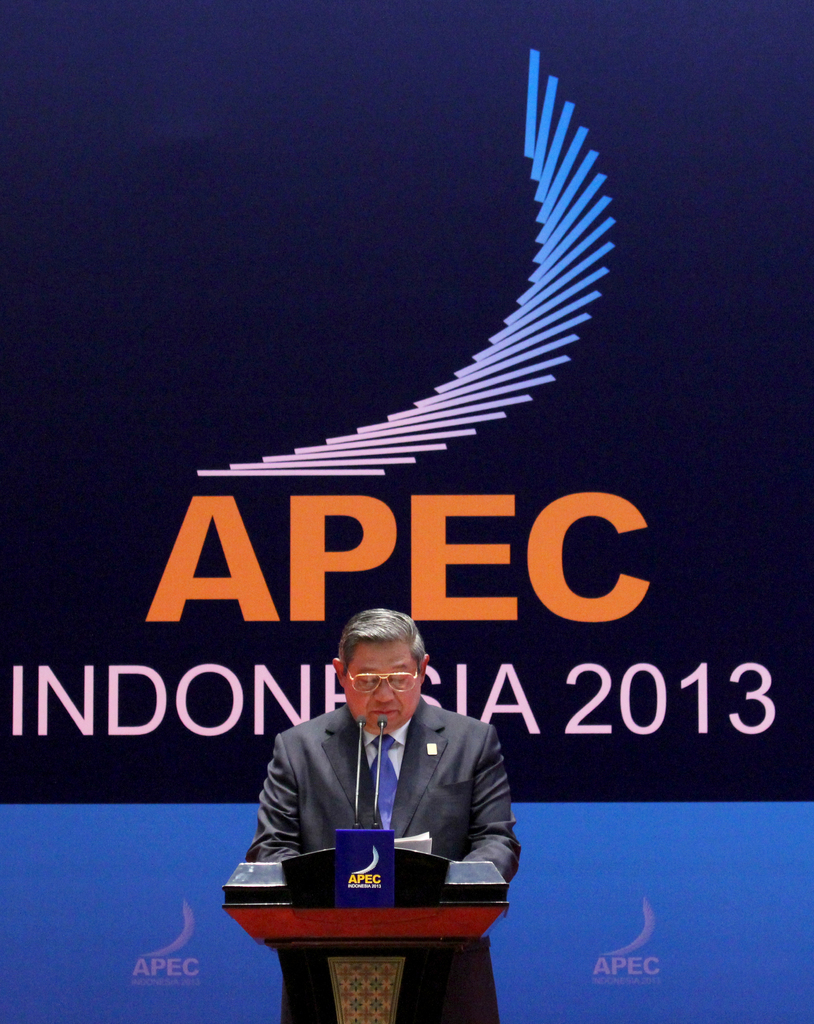Describe the following image.
 The image captures a significant moment at the APEC Indonesia 2013 conference. A man, donned in a suit and glasses, is seen delivering a speech at a wooden podium. The seriousness of the event is underscored by the APEC logo prominently displayed on both the podium and the blue wall behind him. The text "APEC INDONESIA 2013" further emphasizes the context and location of the event. The man's engagement with the microphone suggests an ongoing dialogue, possibly addressing important economic and political matters pertinent to the Asia-Pacific region. The image, therefore, serves as a visual record of this international event, encapsulating the essence of diplomatic discourse and cooperation. 